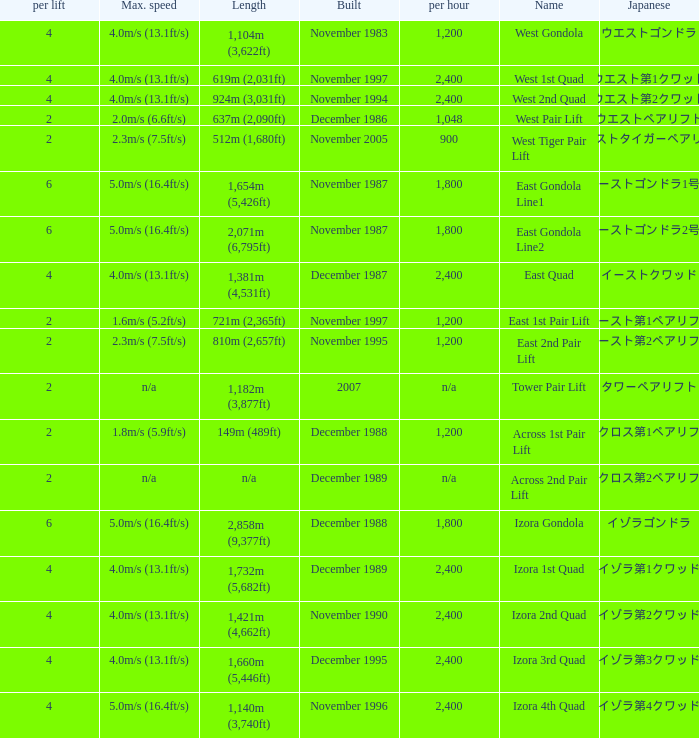How heavy is the  maximum 6.0. 